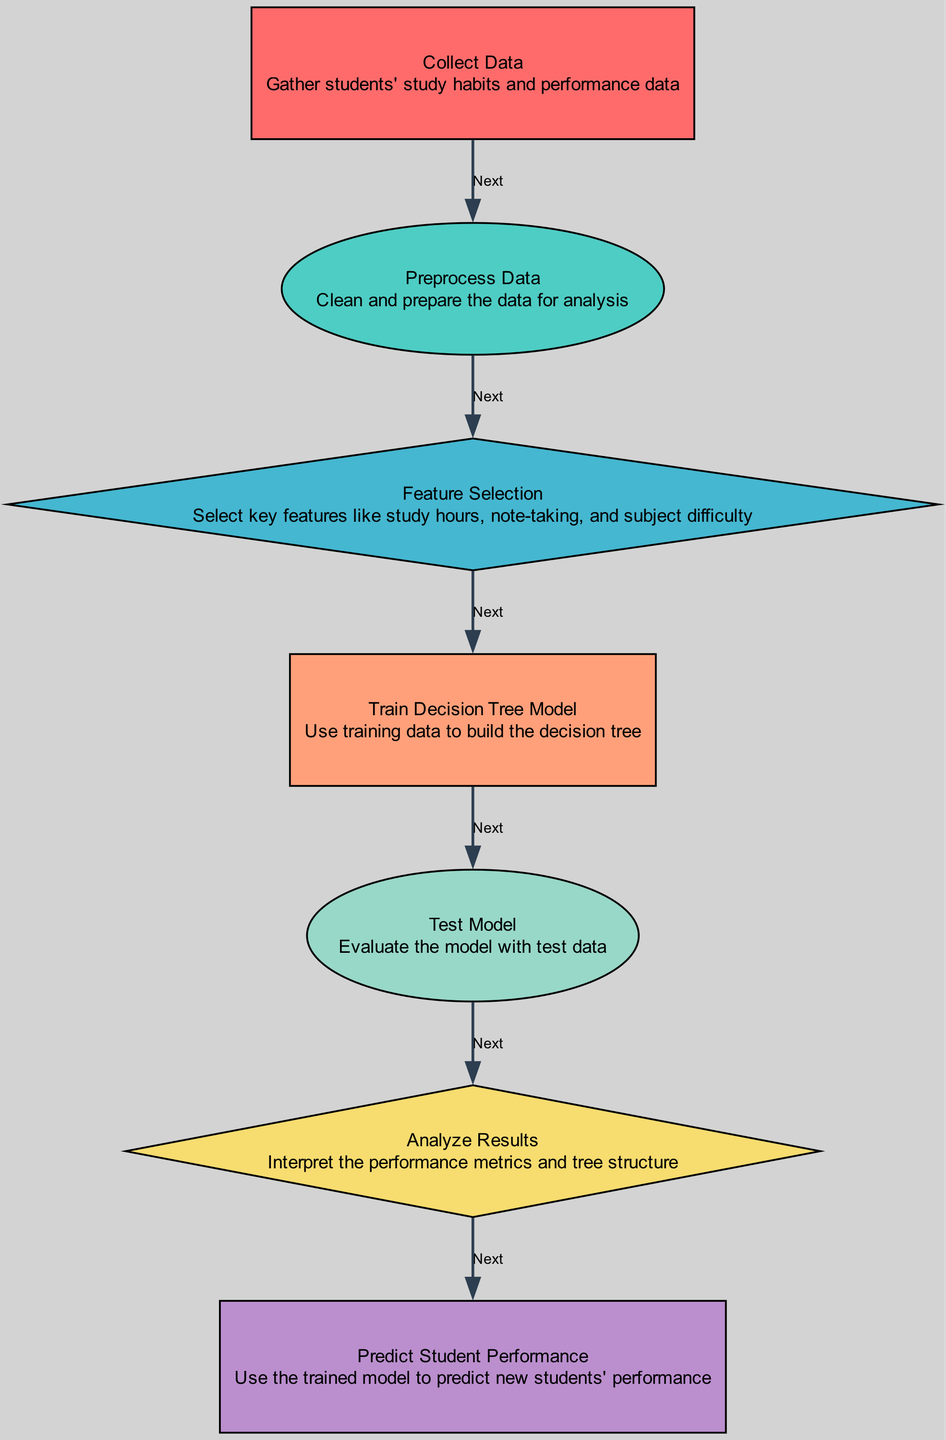What is the first step in the process? The diagram indicates that the first step is labeled "Collect Data," which involves gathering students' study habits and performance data.
Answer: Collect Data How many nodes are present in the diagram? By counting the nodes listed in the diagram, there are a total of seven nodes involved from collecting data to predicting performance.
Answer: Seven What shape represents "Preprocess Data"? The shape that corresponds to "Preprocess Data" is an ellipse, which visually distinguishes it from other steps in the diagram.
Answer: Ellipse What does the "Feature Selection" step focus on? "Feature Selection" focuses on selecting key features like study hours, note-taking, and subject difficulty, as described in the diagram.
Answer: Key features What is the last action taken according to the diagram? The last action in the process is to "Predict Student Performance," which implies the utilization of the trained model for predictions based on the gathered data.
Answer: Predict Student Performance How many edges connect the nodes in the diagram? The diagram shows a total of six edges connecting the nodes, indicating the flow of the process from one step to the next.
Answer: Six What is the purpose of the "Analyze Results" step? The purpose of "Analyze Results" is to interpret the performance metrics and tree structure, aiding in the evaluation of the decision tree model's effectiveness.
Answer: Interpret performance metrics Which node comes after "Test Model"? Following the "Test Model" node, the next step in the process is "Analyze Results," forming a sequential flow from testing to analysis.
Answer: Analyze Results What is the second node in the diagram? The second node after the starting point is "Preprocess Data," which typically involves cleaning and preparing the dataset for further analysis.
Answer: Preprocess Data 